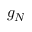<formula> <loc_0><loc_0><loc_500><loc_500>g _ { N }</formula> 